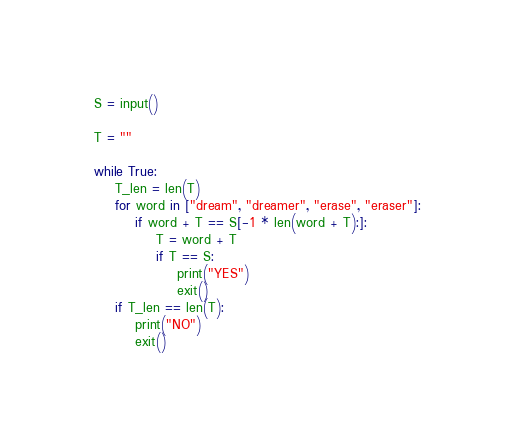Convert code to text. <code><loc_0><loc_0><loc_500><loc_500><_Python_>S = input()

T = ""

while True:
    T_len = len(T)
    for word in ["dream", "dreamer", "erase", "eraser"]:
        if word + T == S[-1 * len(word + T):]:
            T = word + T
            if T == S:
                print("YES")
                exit()
    if T_len == len(T):
        print("NO")
        exit()
</code> 